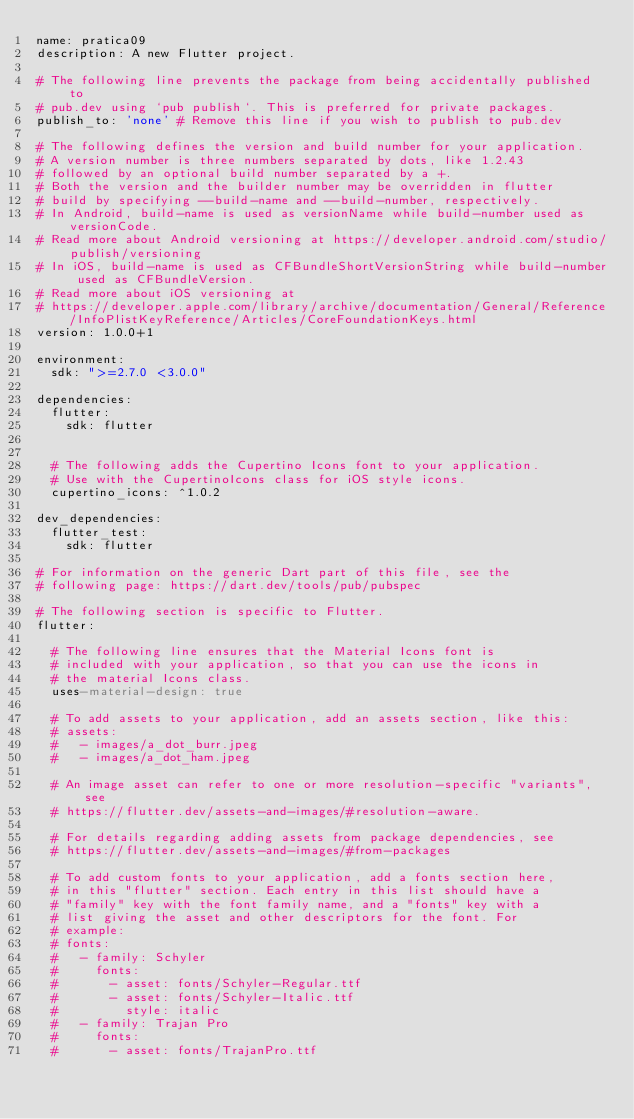Convert code to text. <code><loc_0><loc_0><loc_500><loc_500><_YAML_>name: pratica09
description: A new Flutter project.

# The following line prevents the package from being accidentally published to
# pub.dev using `pub publish`. This is preferred for private packages.
publish_to: 'none' # Remove this line if you wish to publish to pub.dev

# The following defines the version and build number for your application.
# A version number is three numbers separated by dots, like 1.2.43
# followed by an optional build number separated by a +.
# Both the version and the builder number may be overridden in flutter
# build by specifying --build-name and --build-number, respectively.
# In Android, build-name is used as versionName while build-number used as versionCode.
# Read more about Android versioning at https://developer.android.com/studio/publish/versioning
# In iOS, build-name is used as CFBundleShortVersionString while build-number used as CFBundleVersion.
# Read more about iOS versioning at
# https://developer.apple.com/library/archive/documentation/General/Reference/InfoPlistKeyReference/Articles/CoreFoundationKeys.html
version: 1.0.0+1

environment:
  sdk: ">=2.7.0 <3.0.0"

dependencies:
  flutter:
    sdk: flutter


  # The following adds the Cupertino Icons font to your application.
  # Use with the CupertinoIcons class for iOS style icons.
  cupertino_icons: ^1.0.2

dev_dependencies:
  flutter_test:
    sdk: flutter

# For information on the generic Dart part of this file, see the
# following page: https://dart.dev/tools/pub/pubspec

# The following section is specific to Flutter.
flutter:

  # The following line ensures that the Material Icons font is
  # included with your application, so that you can use the icons in
  # the material Icons class.
  uses-material-design: true

  # To add assets to your application, add an assets section, like this:
  # assets:
  #   - images/a_dot_burr.jpeg
  #   - images/a_dot_ham.jpeg

  # An image asset can refer to one or more resolution-specific "variants", see
  # https://flutter.dev/assets-and-images/#resolution-aware.

  # For details regarding adding assets from package dependencies, see
  # https://flutter.dev/assets-and-images/#from-packages

  # To add custom fonts to your application, add a fonts section here,
  # in this "flutter" section. Each entry in this list should have a
  # "family" key with the font family name, and a "fonts" key with a
  # list giving the asset and other descriptors for the font. For
  # example:
  # fonts:
  #   - family: Schyler
  #     fonts:
  #       - asset: fonts/Schyler-Regular.ttf
  #       - asset: fonts/Schyler-Italic.ttf
  #         style: italic
  #   - family: Trajan Pro
  #     fonts:
  #       - asset: fonts/TrajanPro.ttf</code> 